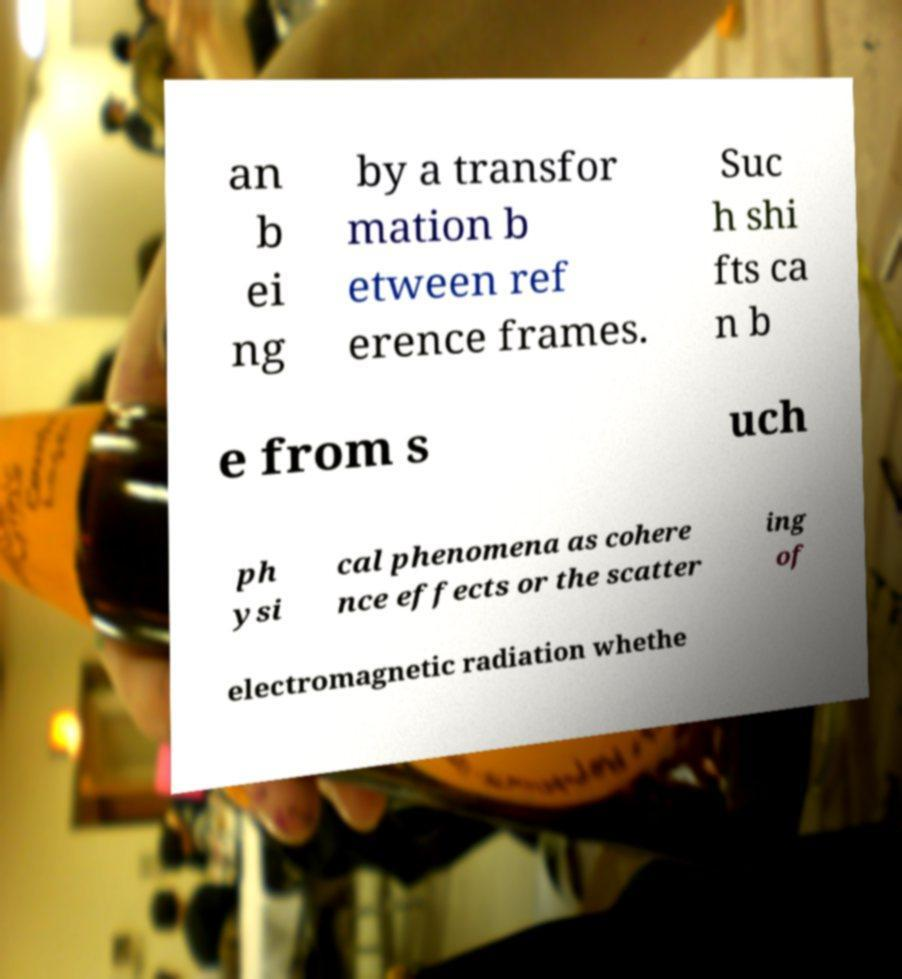Please identify and transcribe the text found in this image. an b ei ng by a transfor mation b etween ref erence frames. Suc h shi fts ca n b e from s uch ph ysi cal phenomena as cohere nce effects or the scatter ing of electromagnetic radiation whethe 